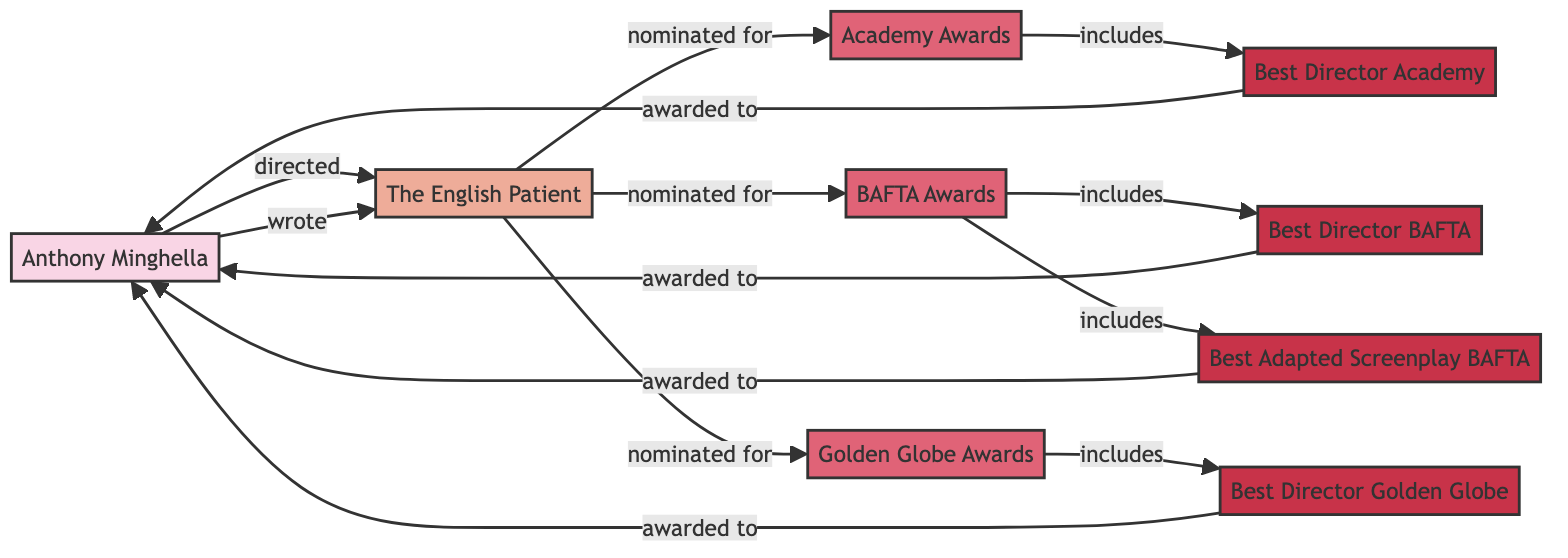What is the title of the film associated with Anthony Minghella? The diagram shows a direct connection between Anthony Minghella and a node for "The English Patient". Thus, the title of the film is clearly indicated.
Answer: The English Patient How many awards is "The English Patient" nominated for? By examining the connections from "The English Patient", there are three links to award nodes: Academy Awards, BAFTA Awards, and Golden Globe Awards. Therefore, it is nominated for three awards.
Answer: 3 Which role is associated with Anthony Minghella for "The English Patient"? There are two roles listed for Anthony Minghella in relation to "The English Patient": "Directed" and "Wrote". This shows his involvement in both capacities.
Answer: Director, Writer How many categories are included in the BAFTA Awards? The BAFTA Awards node connects to two category nodes: Best Director BAFTA and Best Adapted Screenplay. Counting these, we find that there are two categories included.
Answer: 2 Which award did Anthony Minghella receive for "The English Patient"? The diagram connects Anthony Minghella to multiple categories that designate awards; the paths from the categories indicate he was awarded for Best Director at both the Academy and BAFTA, among others.
Answer: Best Director, Best Adapted Screenplay What type of diagram represents the relationships and entities in this information? This specific representation focuses on showing entities and the relationships between them, characteristic of a network structure. Therefore, the type of diagram utilized is a Network Diagram.
Answer: Network Diagram How many nodes represent award categories in the diagram? Reviewing the diagram reveals there are four distinct category nodes: Best Director Academy, Best Director BAFTA, Best Adapted Screenplay BAFTA, and Best Director Golden Globe. By counting these, we find there are four category nodes.
Answer: 4 What relationship is indicated between Anthony Minghella and "The English Patient"? The diagram clearly illustrates two distinct relationships labeled as "directed" and "wrote", showing Minghella's dual roles with the film.
Answer: Directed, Wrote Which award includes the category for Best Adapted Screenplay? The relationship linking the BAFTA Awards node to the Best Adapted Screenplay category indicates this specific award includes that category.
Answer: BAFTA Awards 